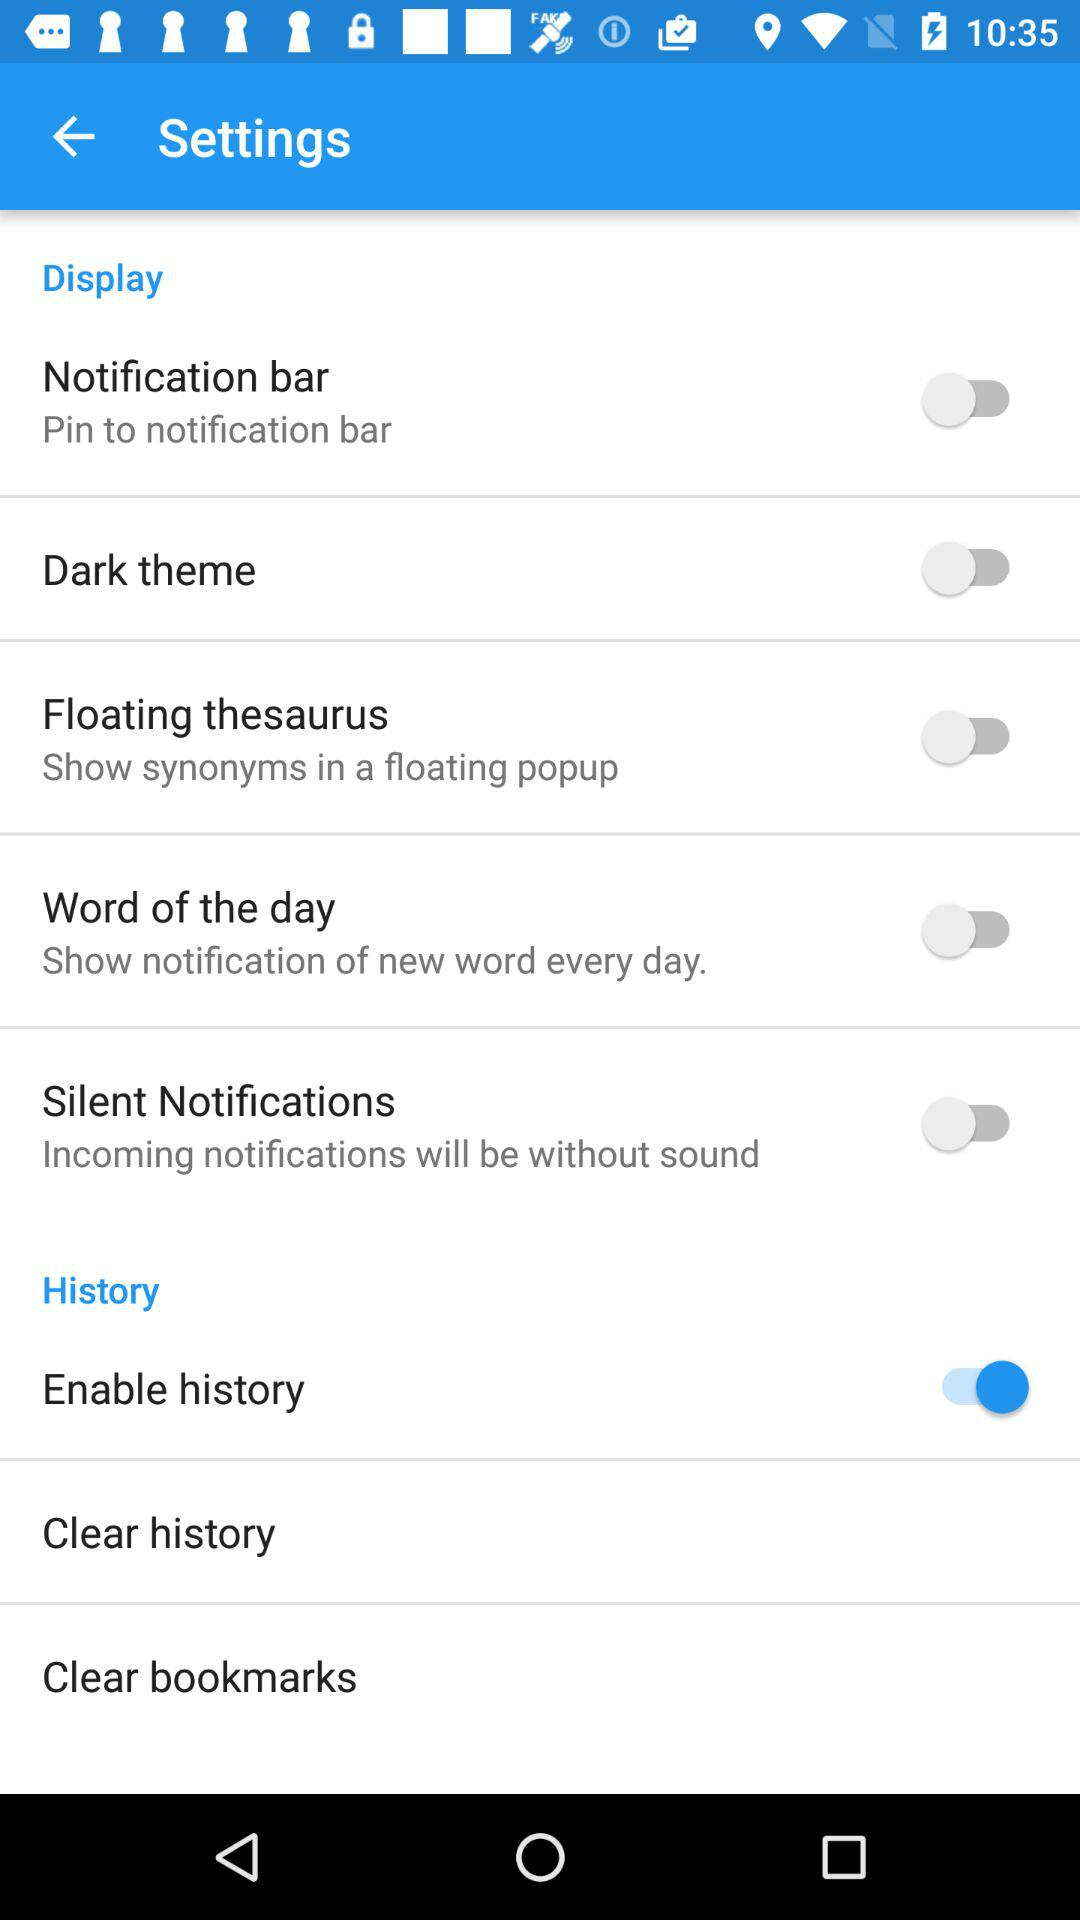What is the status of "Word of the day"? The status is off. 